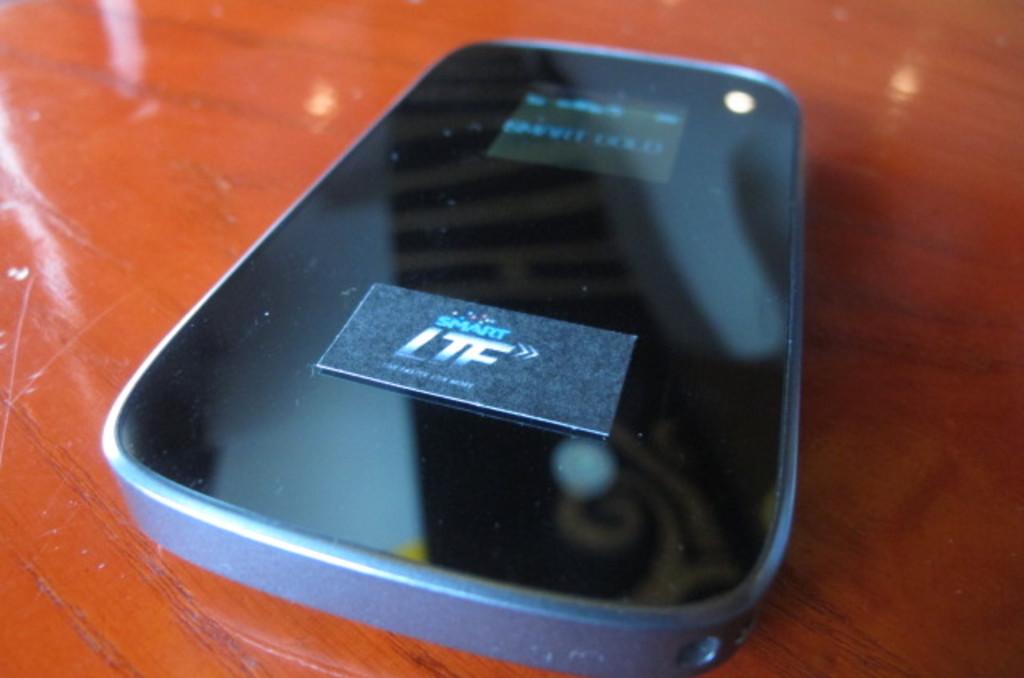What letters are on the sticker?
Keep it short and to the point. Ltf. What is the brand of the device?
Make the answer very short. Ltf. 